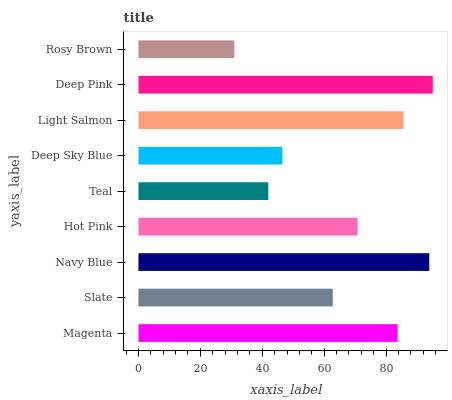Is Rosy Brown the minimum?
Answer yes or no. Yes. Is Deep Pink the maximum?
Answer yes or no. Yes. Is Slate the minimum?
Answer yes or no. No. Is Slate the maximum?
Answer yes or no. No. Is Magenta greater than Slate?
Answer yes or no. Yes. Is Slate less than Magenta?
Answer yes or no. Yes. Is Slate greater than Magenta?
Answer yes or no. No. Is Magenta less than Slate?
Answer yes or no. No. Is Hot Pink the high median?
Answer yes or no. Yes. Is Hot Pink the low median?
Answer yes or no. Yes. Is Light Salmon the high median?
Answer yes or no. No. Is Deep Pink the low median?
Answer yes or no. No. 